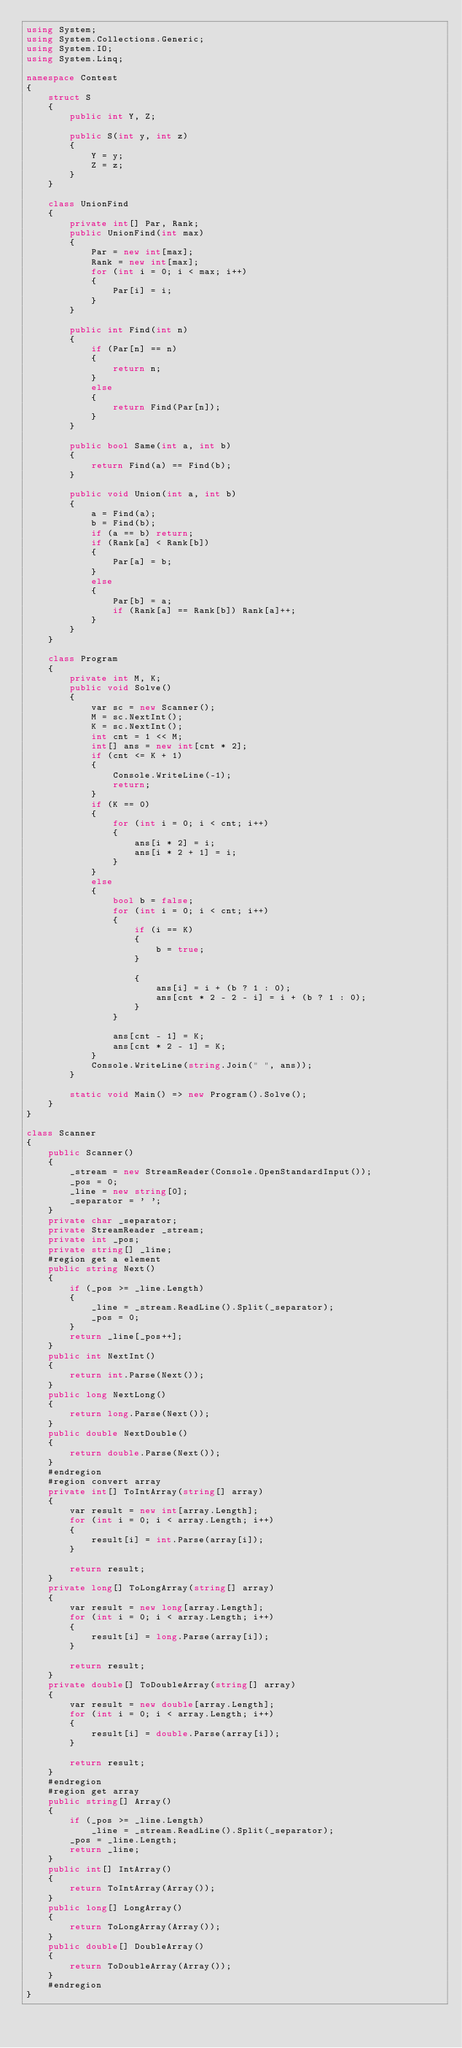<code> <loc_0><loc_0><loc_500><loc_500><_C#_>using System;
using System.Collections.Generic;
using System.IO;
using System.Linq;

namespace Contest
{
    struct S
    {
        public int Y, Z;

        public S(int y, int z)
        {
            Y = y;
            Z = z;
        }
    }

    class UnionFind
    {
        private int[] Par, Rank;
        public UnionFind(int max)
        {
            Par = new int[max];
            Rank = new int[max];
            for (int i = 0; i < max; i++)
            {
                Par[i] = i;
            }
        }

        public int Find(int n)
        {
            if (Par[n] == n)
            {
                return n;
            }
            else
            {
                return Find(Par[n]);
            }
        }

        public bool Same(int a, int b)
        {
            return Find(a) == Find(b);
        }

        public void Union(int a, int b)
        {
            a = Find(a);
            b = Find(b);
            if (a == b) return;
            if (Rank[a] < Rank[b])
            {
                Par[a] = b;
            }
            else
            {
                Par[b] = a;
                if (Rank[a] == Rank[b]) Rank[a]++;
            }
        }
    }

    class Program
    {
        private int M, K;
        public void Solve()
        {
            var sc = new Scanner();
            M = sc.NextInt();
            K = sc.NextInt();
            int cnt = 1 << M;
            int[] ans = new int[cnt * 2];
            if (cnt <= K + 1)
            {
                Console.WriteLine(-1);
                return;
            }
            if (K == 0)
            {
                for (int i = 0; i < cnt; i++)
                {
                    ans[i * 2] = i;
                    ans[i * 2 + 1] = i;
                }
            }
            else
            {
                bool b = false;
                for (int i = 0; i < cnt; i++)
                {
                    if (i == K)
                    {
                        b = true;
                    }

                    {
                        ans[i] = i + (b ? 1 : 0);
                        ans[cnt * 2 - 2 - i] = i + (b ? 1 : 0);
                    }
                }

                ans[cnt - 1] = K;
                ans[cnt * 2 - 1] = K;
            }
            Console.WriteLine(string.Join(" ", ans));
        }

        static void Main() => new Program().Solve();
    }
}

class Scanner
{
    public Scanner()
    {
        _stream = new StreamReader(Console.OpenStandardInput());
        _pos = 0;
        _line = new string[0];
        _separator = ' ';
    }
    private char _separator;
    private StreamReader _stream;
    private int _pos;
    private string[] _line;
    #region get a element
    public string Next()
    {
        if (_pos >= _line.Length)
        {
            _line = _stream.ReadLine().Split(_separator);
            _pos = 0;
        }
        return _line[_pos++];
    }
    public int NextInt()
    {
        return int.Parse(Next());
    }
    public long NextLong()
    {
        return long.Parse(Next());
    }
    public double NextDouble()
    {
        return double.Parse(Next());
    }
    #endregion
    #region convert array
    private int[] ToIntArray(string[] array)
    {
        var result = new int[array.Length];
        for (int i = 0; i < array.Length; i++)
        {
            result[i] = int.Parse(array[i]);
        }

        return result;
    }
    private long[] ToLongArray(string[] array)
    {
        var result = new long[array.Length];
        for (int i = 0; i < array.Length; i++)
        {
            result[i] = long.Parse(array[i]);
        }

        return result;
    }
    private double[] ToDoubleArray(string[] array)
    {
        var result = new double[array.Length];
        for (int i = 0; i < array.Length; i++)
        {
            result[i] = double.Parse(array[i]);
        }

        return result;
    }
    #endregion
    #region get array
    public string[] Array()
    {
        if (_pos >= _line.Length)
            _line = _stream.ReadLine().Split(_separator);
        _pos = _line.Length;
        return _line;
    }
    public int[] IntArray()
    {
        return ToIntArray(Array());
    }
    public long[] LongArray()
    {
        return ToLongArray(Array());
    }
    public double[] DoubleArray()
    {
        return ToDoubleArray(Array());
    }
    #endregion
}</code> 